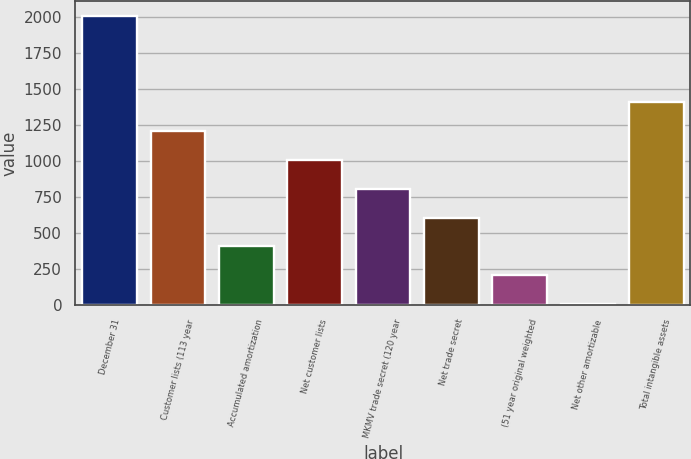Convert chart to OTSL. <chart><loc_0><loc_0><loc_500><loc_500><bar_chart><fcel>December 31<fcel>Customer lists (113 year<fcel>Accumulated amortization<fcel>Net customer lists<fcel>MKMV trade secret (120 year<fcel>Net trade secret<fcel>(51 year original weighted<fcel>Net other amortizable<fcel>Total intangible assets<nl><fcel>2005<fcel>1205.6<fcel>406.2<fcel>1005.75<fcel>805.9<fcel>606.05<fcel>206.35<fcel>6.5<fcel>1405.45<nl></chart> 